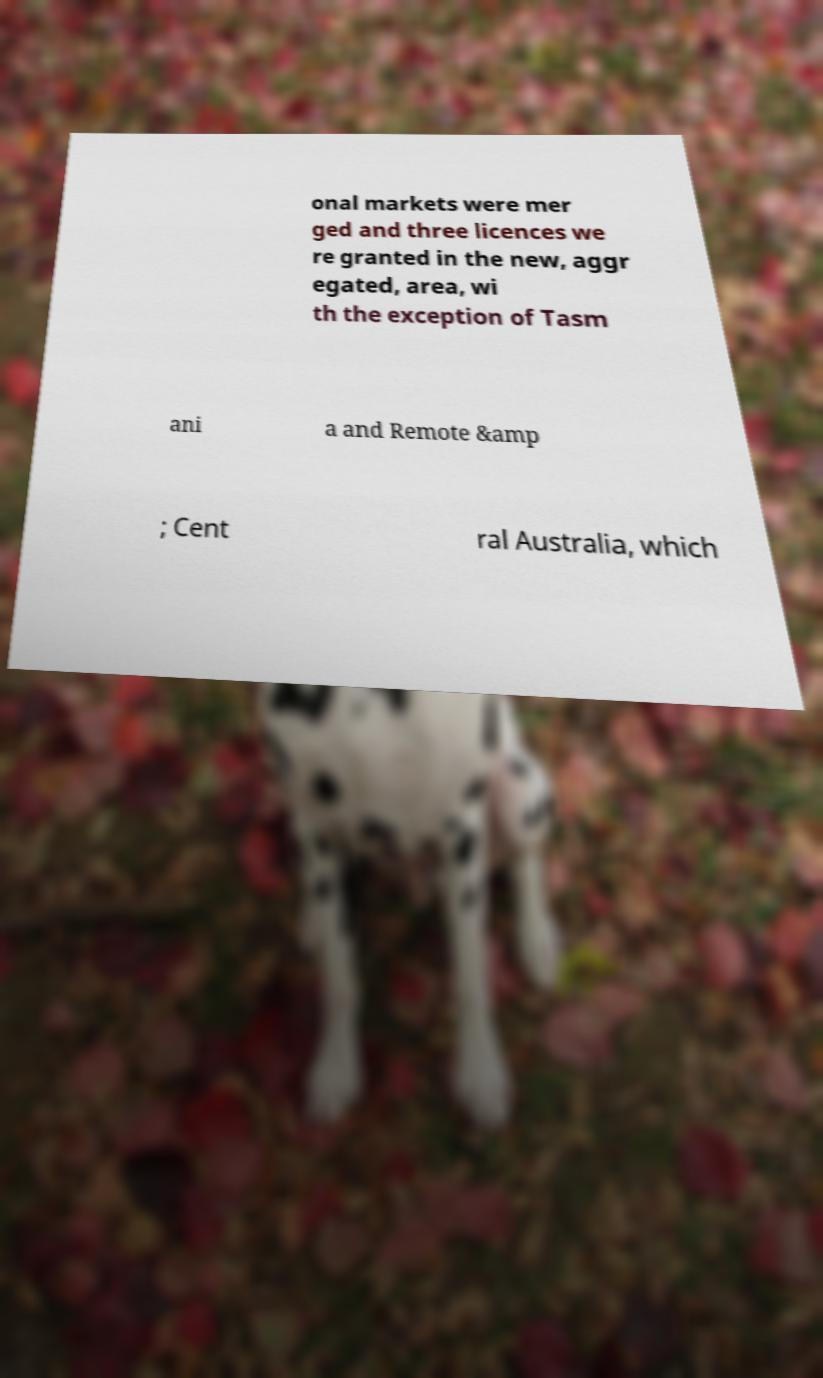What messages or text are displayed in this image? I need them in a readable, typed format. onal markets were mer ged and three licences we re granted in the new, aggr egated, area, wi th the exception of Tasm ani a and Remote &amp ; Cent ral Australia, which 